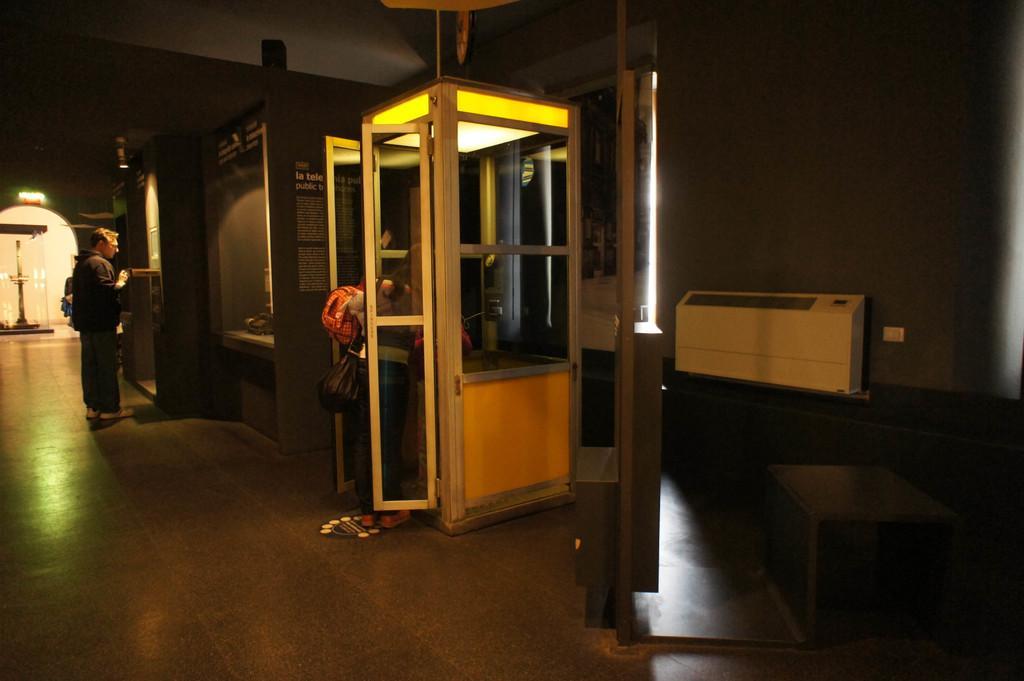Can you describe this image briefly? In this image we can see few people and they are carrying some objects. There are few boards on the walls. There are few objects at the right side of the image. There is an object at the left side of the image. 